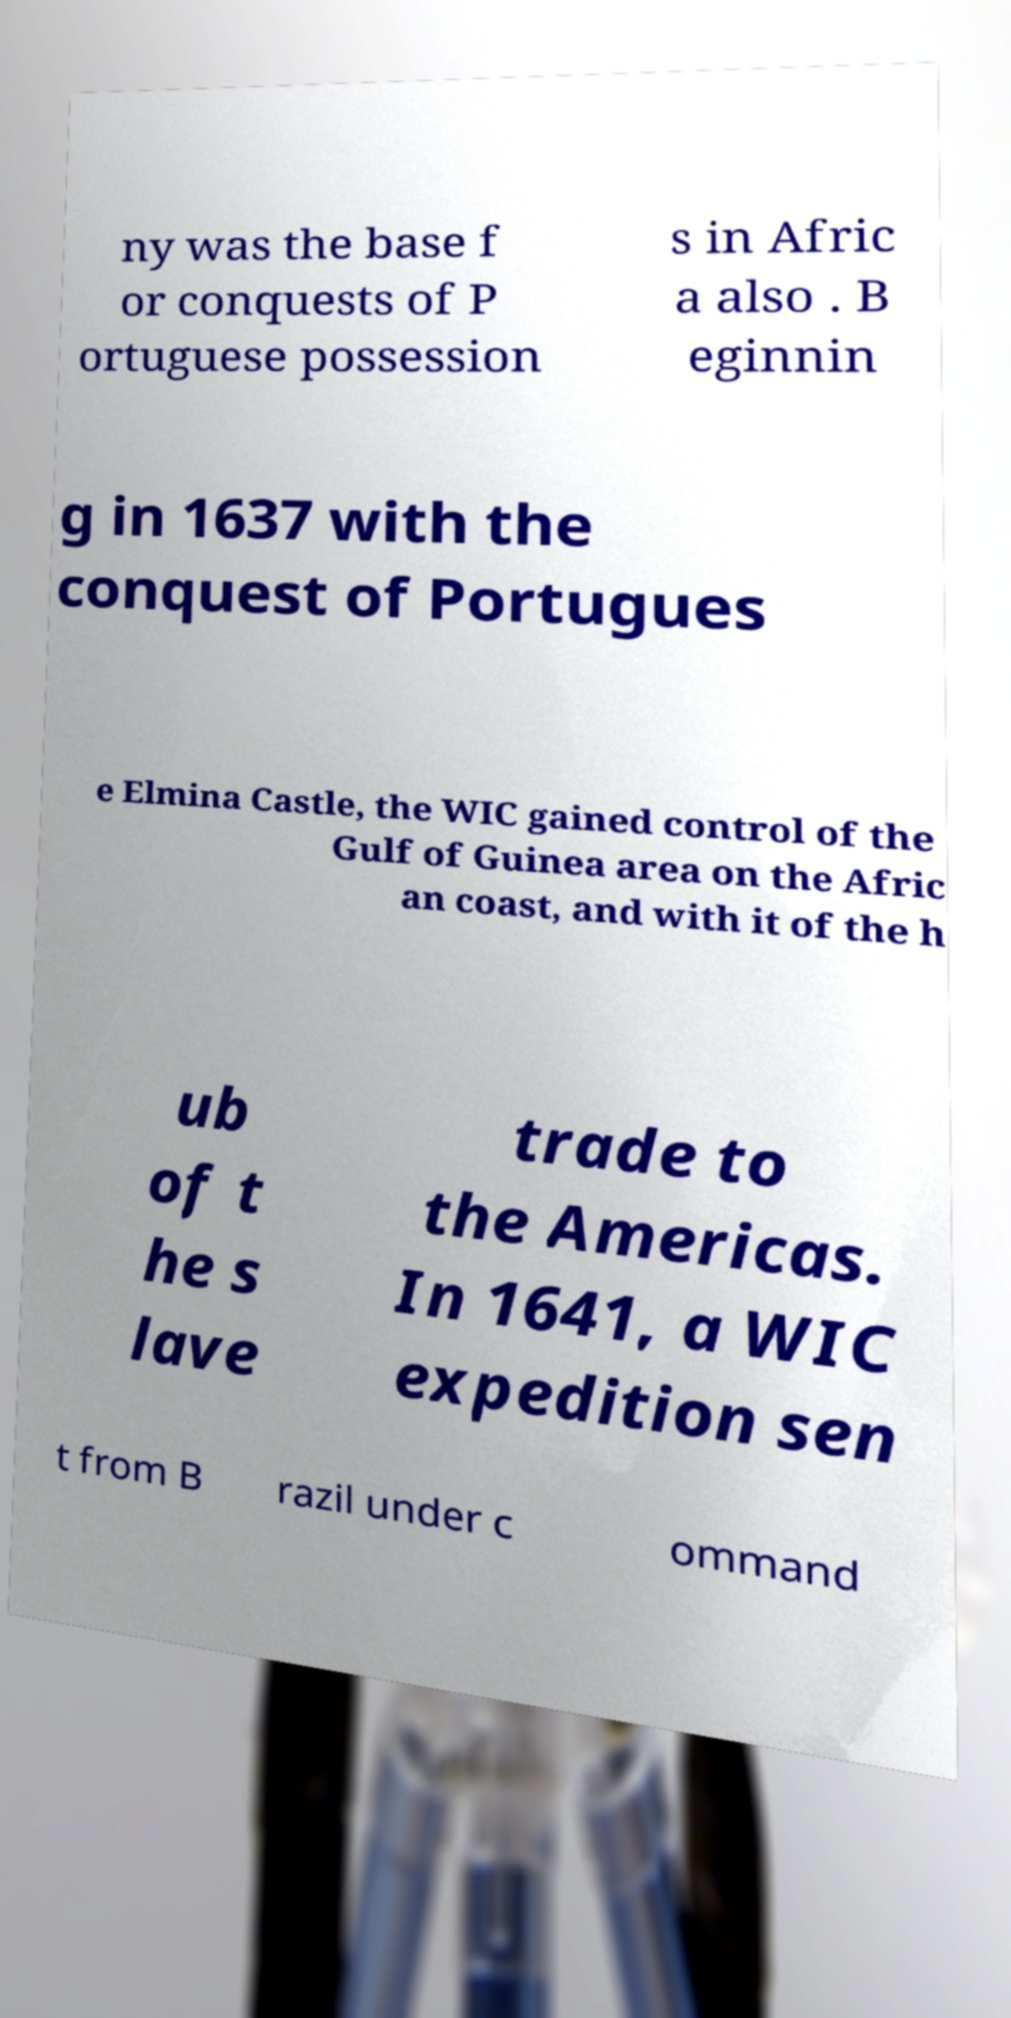Please read and relay the text visible in this image. What does it say? ny was the base f or conquests of P ortuguese possession s in Afric a also . B eginnin g in 1637 with the conquest of Portugues e Elmina Castle, the WIC gained control of the Gulf of Guinea area on the Afric an coast, and with it of the h ub of t he s lave trade to the Americas. In 1641, a WIC expedition sen t from B razil under c ommand 